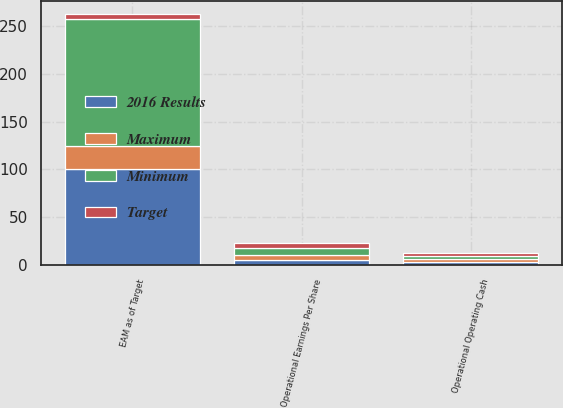Convert chart to OTSL. <chart><loc_0><loc_0><loc_500><loc_500><stacked_bar_chart><ecel><fcel>Operational Earnings Per Share<fcel>Operational Operating Cash<fcel>EAM as of Target<nl><fcel>Maximum<fcel>4.82<fcel>2.79<fcel>25<nl><fcel>2016 Results<fcel>5.35<fcel>3.18<fcel>100<nl><fcel>Target<fcel>5.88<fcel>3.56<fcel>5.35<nl><fcel>Minimum<fcel>7.11<fcel>3<fcel>133<nl></chart> 